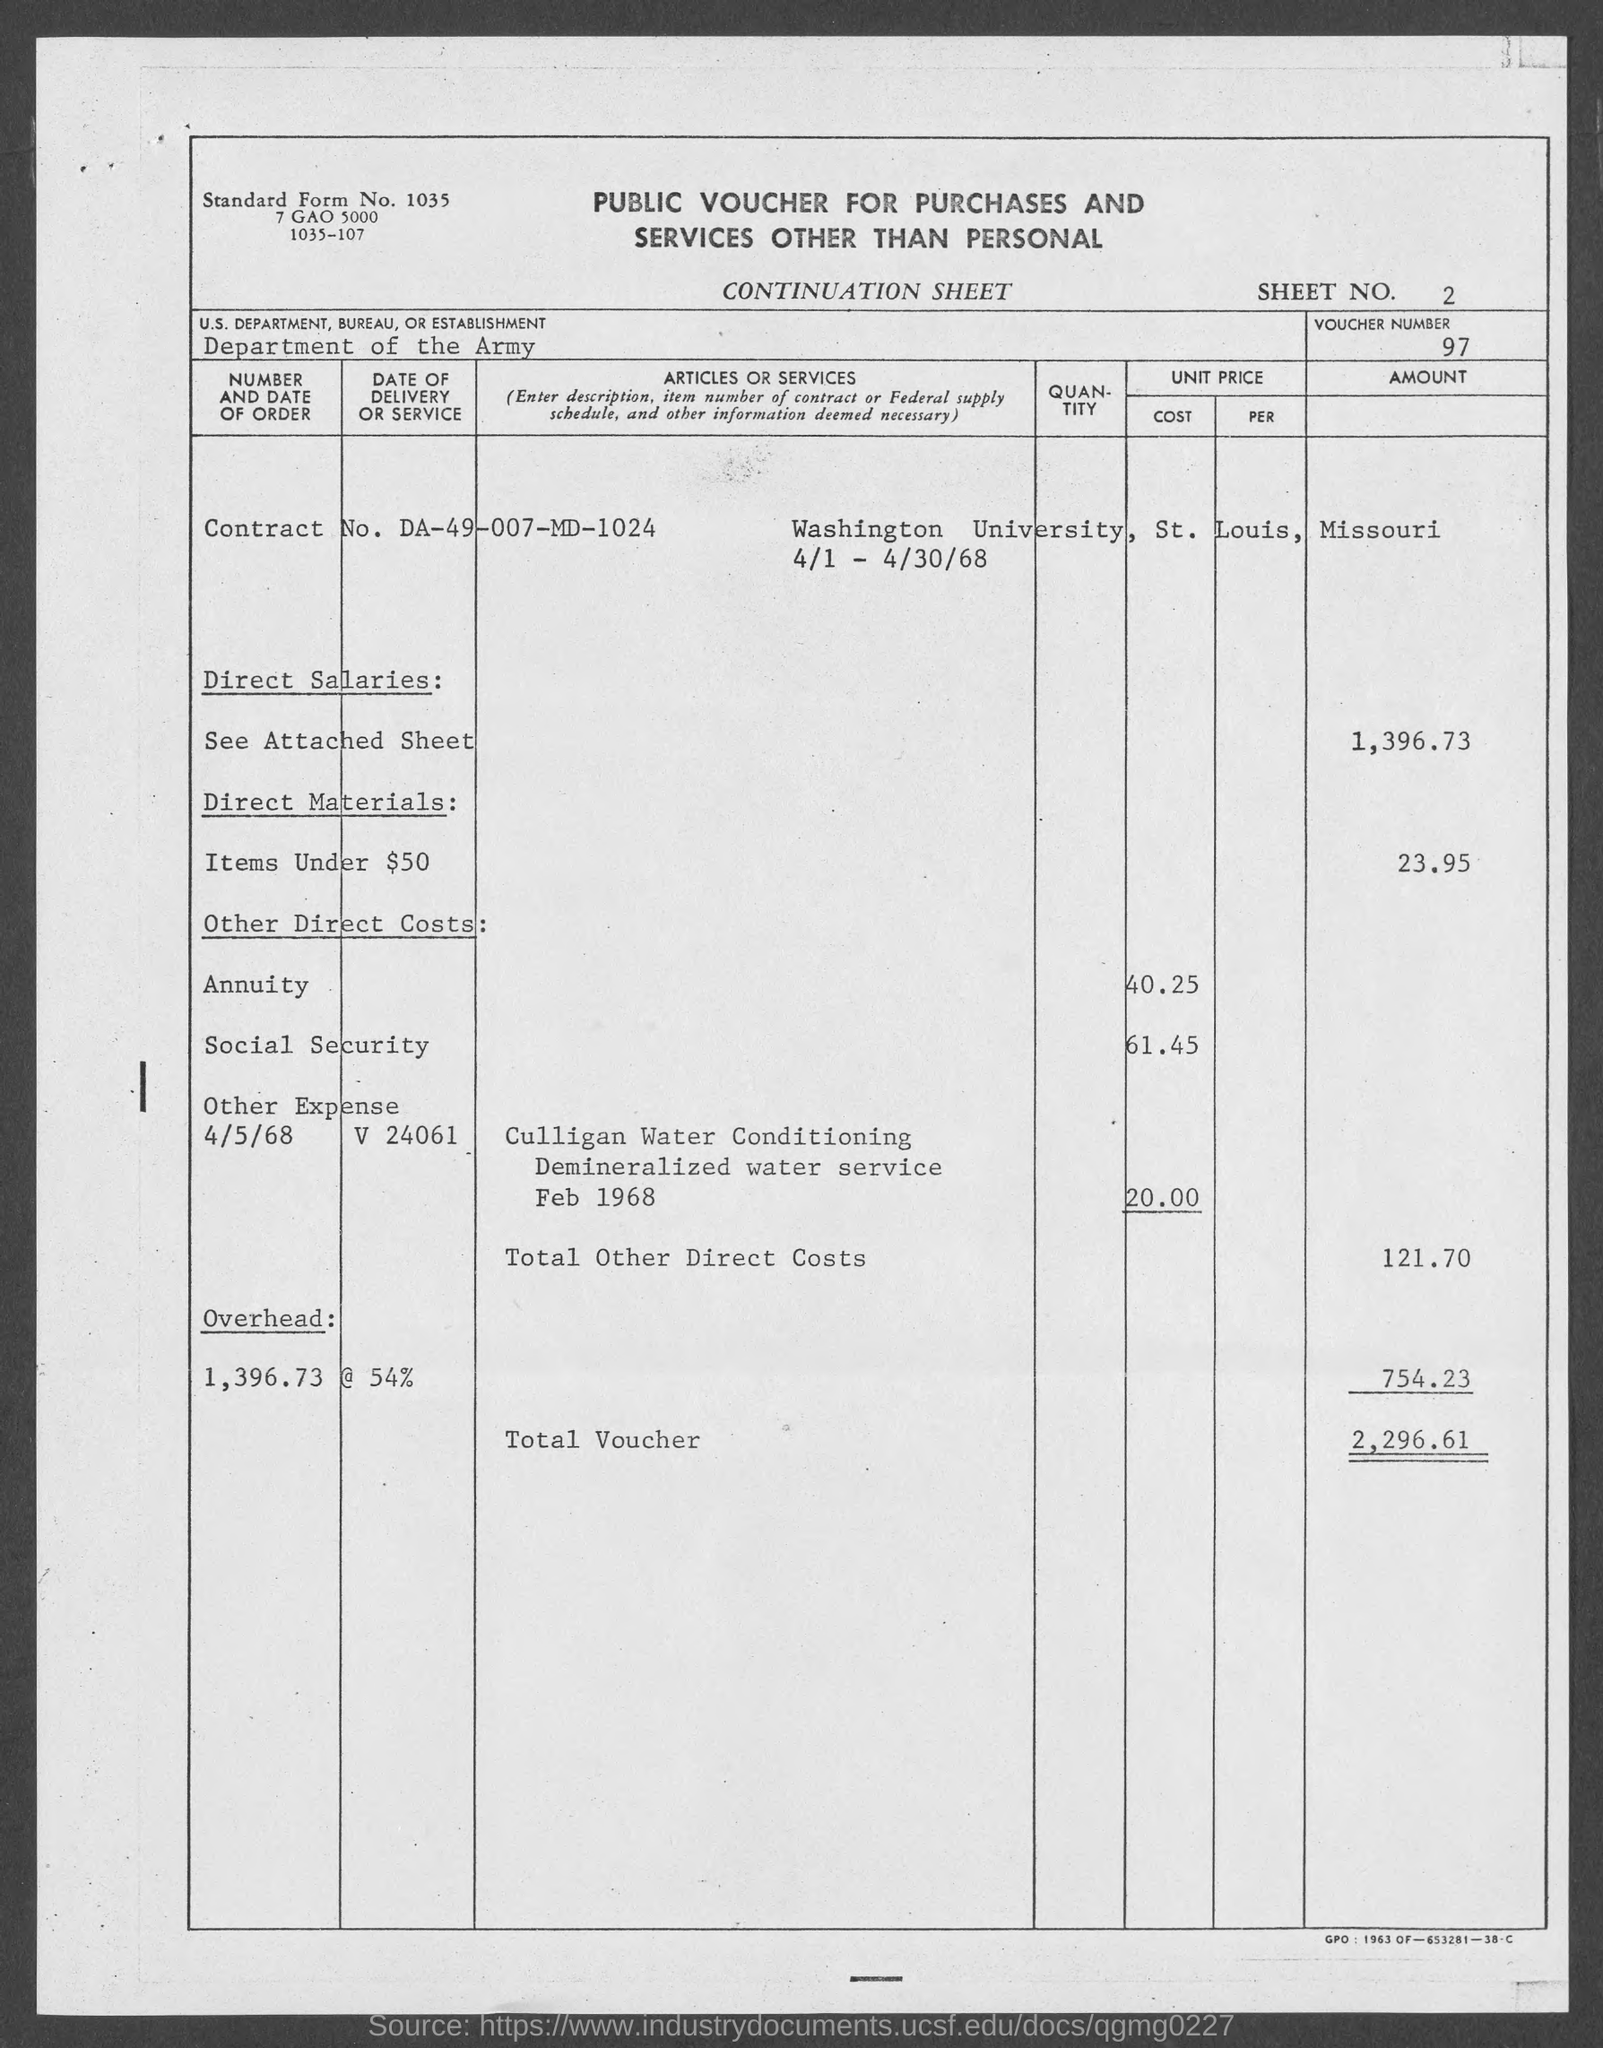Indicate a few pertinent items in this graphic. The standard form number indicated in the voucher is 1035.. The sheet number mentioned in the voucher is 2. The social security cost mentioned in the voucher is 61.45. The voucher number provided in the document is 97.. You are requesting information regarding the overhead cost stated on the voucher, which is 754.23... 